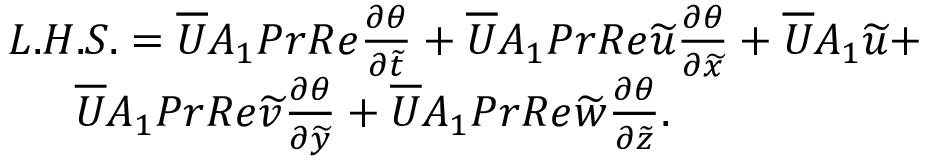Convert formula to latex. <formula><loc_0><loc_0><loc_500><loc_500>\begin{array} { r } { L . H . S . = \overline { U } A _ { 1 } P r R e { \frac { \partial \theta } { \partial \widetilde { t } } } + \overline { U } A _ { 1 } P r R e \widetilde { u } { \frac { \partial \theta } { \partial \widetilde { x } } } + \overline { U } A _ { 1 } \widetilde { u } + } \\ { \overline { U } A _ { 1 } P r R e \widetilde { v } { \frac { \partial \theta } { \partial \widetilde { y } } } + \overline { U } A _ { 1 } P r R e \widetilde { w } { \frac { \partial \theta } { \partial \widetilde { z } } } . } \end{array}</formula> 